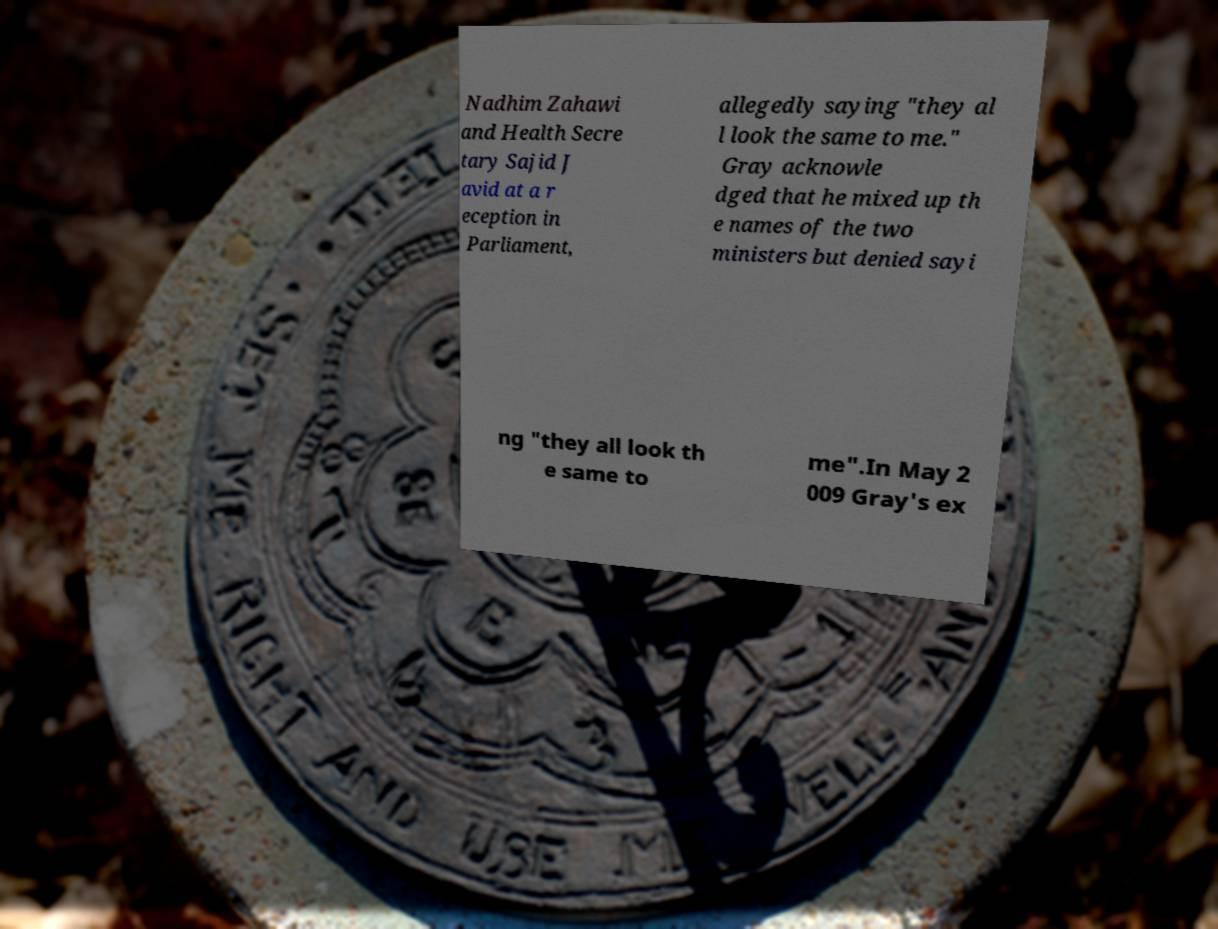For documentation purposes, I need the text within this image transcribed. Could you provide that? Nadhim Zahawi and Health Secre tary Sajid J avid at a r eception in Parliament, allegedly saying "they al l look the same to me." Gray acknowle dged that he mixed up th e names of the two ministers but denied sayi ng "they all look th e same to me".In May 2 009 Gray's ex 